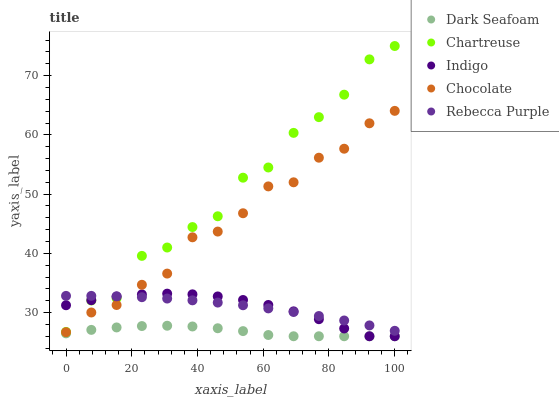Does Dark Seafoam have the minimum area under the curve?
Answer yes or no. Yes. Does Chartreuse have the maximum area under the curve?
Answer yes or no. Yes. Does Indigo have the minimum area under the curve?
Answer yes or no. No. Does Indigo have the maximum area under the curve?
Answer yes or no. No. Is Rebecca Purple the smoothest?
Answer yes or no. Yes. Is Chartreuse the roughest?
Answer yes or no. Yes. Is Indigo the smoothest?
Answer yes or no. No. Is Indigo the roughest?
Answer yes or no. No. Does Dark Seafoam have the lowest value?
Answer yes or no. Yes. Does Chartreuse have the lowest value?
Answer yes or no. No. Does Chartreuse have the highest value?
Answer yes or no. Yes. Does Indigo have the highest value?
Answer yes or no. No. Is Chocolate less than Chartreuse?
Answer yes or no. Yes. Is Chartreuse greater than Dark Seafoam?
Answer yes or no. Yes. Does Indigo intersect Rebecca Purple?
Answer yes or no. Yes. Is Indigo less than Rebecca Purple?
Answer yes or no. No. Is Indigo greater than Rebecca Purple?
Answer yes or no. No. Does Chocolate intersect Chartreuse?
Answer yes or no. No. 